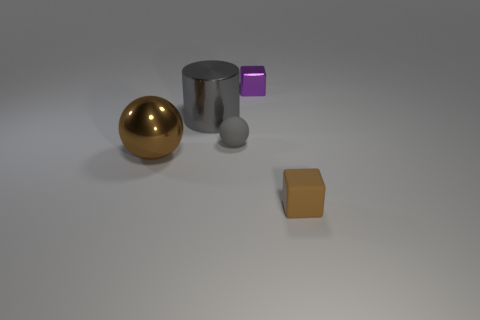What materials do the objects appear to be made of? The objects seem to be rendered with materials that simulate different finishes; the ball looks like polished gold, the cylinder represents a reflective metal possibly steel, the cube could be a matte finish plastic due to its slightly non-reflective surface, the smaller sphere seems to portray a diffuse material like stone or clay, and the square has a flat color suggesting it could be a painted wooden block. 